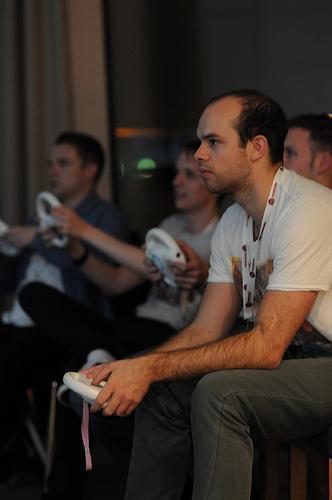How many men holding consoles?
Give a very brief answer. 4. 